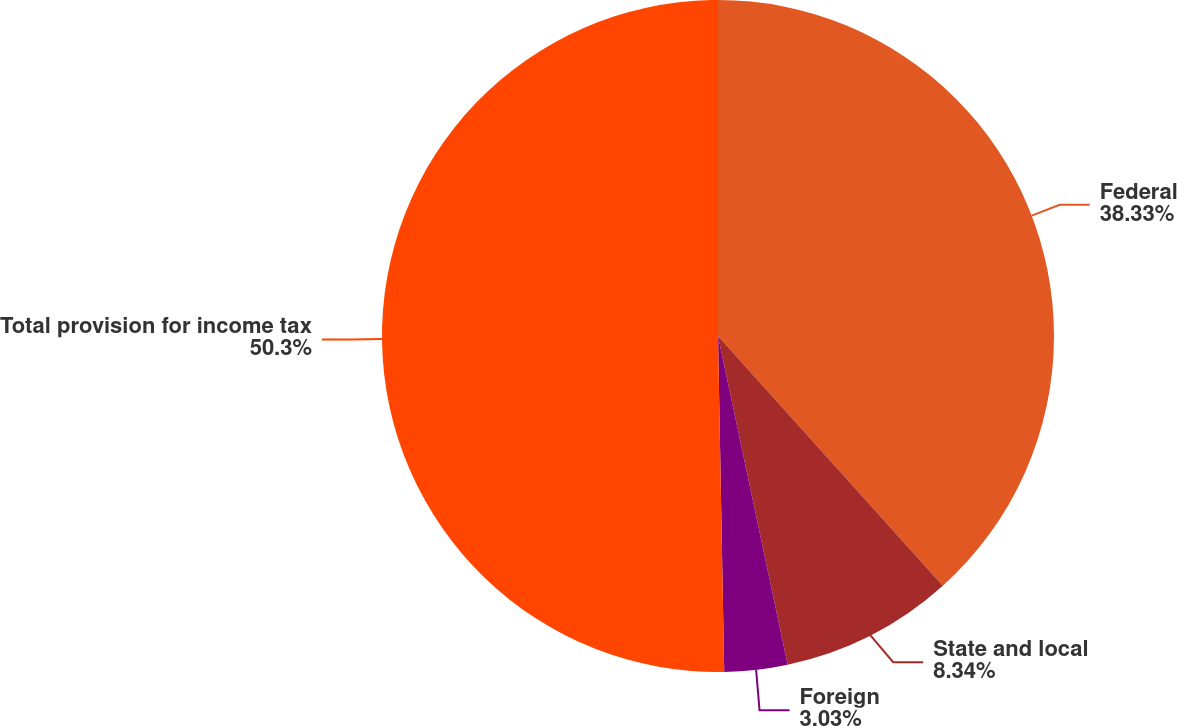Convert chart. <chart><loc_0><loc_0><loc_500><loc_500><pie_chart><fcel>Federal<fcel>State and local<fcel>Foreign<fcel>Total provision for income tax<nl><fcel>38.33%<fcel>8.34%<fcel>3.03%<fcel>50.29%<nl></chart> 